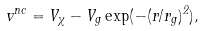<formula> <loc_0><loc_0><loc_500><loc_500>v ^ { n c } = V _ { \chi } - V _ { g } \exp ( - ( r / r _ { g } ) ^ { 2 } ) ,</formula> 